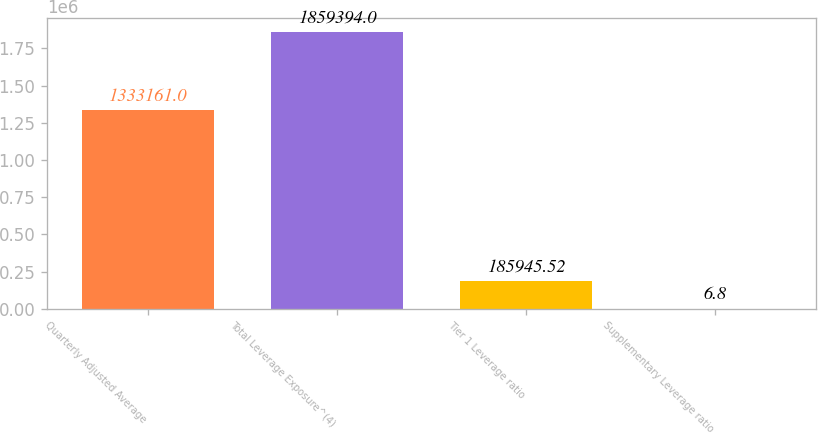<chart> <loc_0><loc_0><loc_500><loc_500><bar_chart><fcel>Quarterly Adjusted Average<fcel>Total Leverage Exposure^(4)<fcel>Tier 1 Leverage ratio<fcel>Supplementary Leverage ratio<nl><fcel>1.33316e+06<fcel>1.85939e+06<fcel>185946<fcel>6.8<nl></chart> 